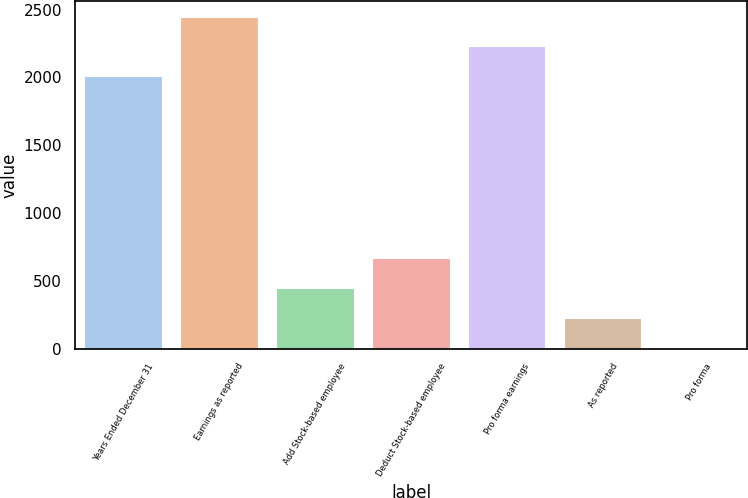Convert chart. <chart><loc_0><loc_0><loc_500><loc_500><bar_chart><fcel>Years Ended December 31<fcel>Earnings as reported<fcel>Add Stock-based employee<fcel>Deduct Stock-based employee<fcel>Pro forma earnings<fcel>As reported<fcel>Pro forma<nl><fcel>2004<fcel>2442.02<fcel>438.89<fcel>657.9<fcel>2223.01<fcel>219.88<fcel>0.87<nl></chart> 